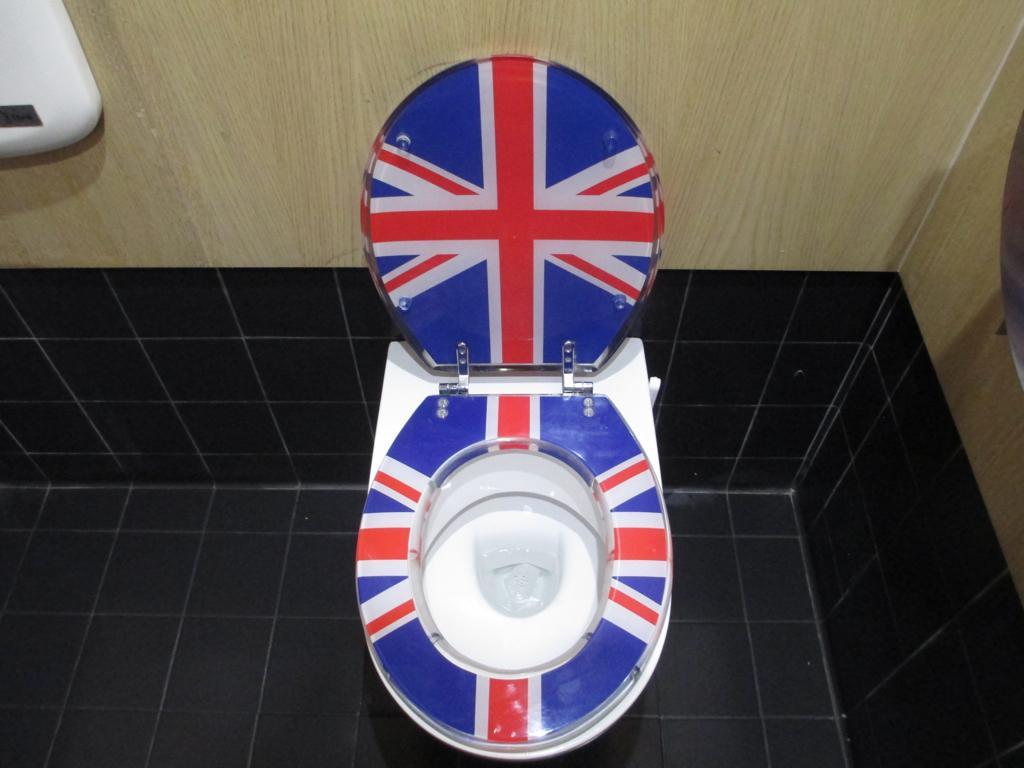Describe this image in one or two sentences. In this picture we can see a toilet seat and walls. 